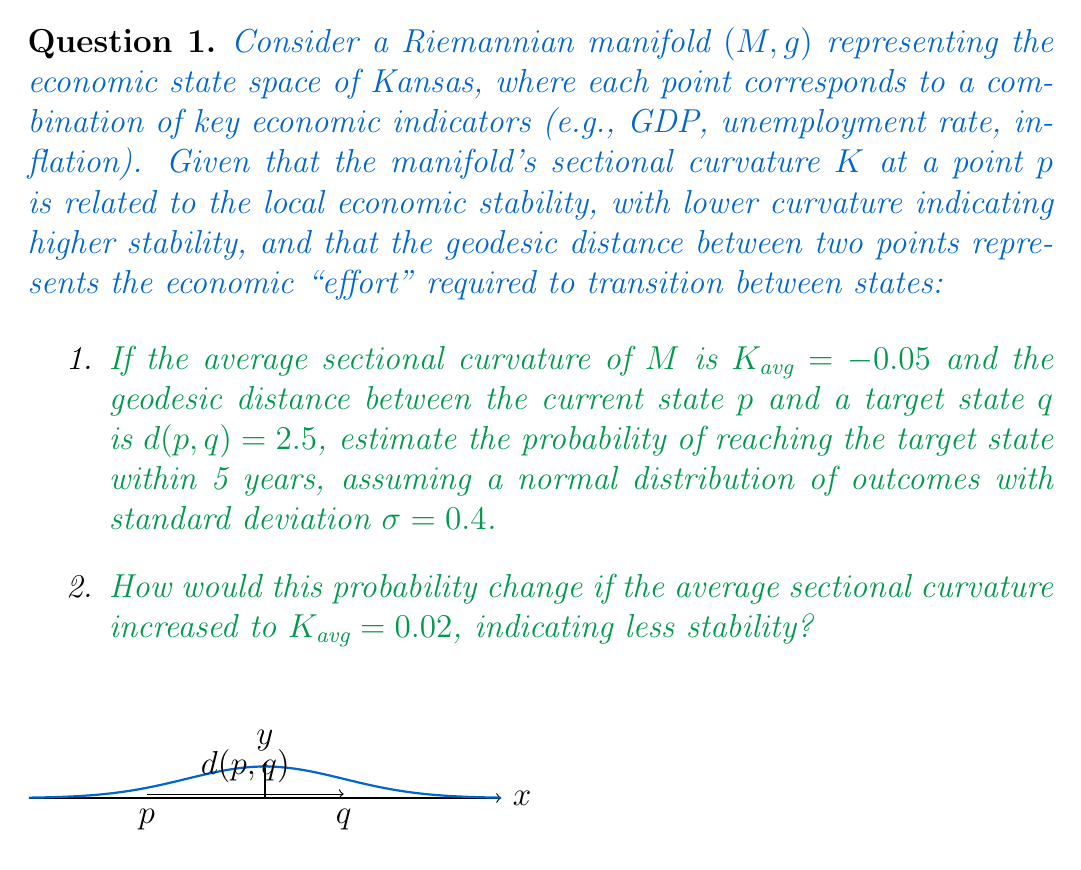Teach me how to tackle this problem. Let's approach this problem step-by-step:

1. First, we need to understand the relationship between sectional curvature and economic stability. Lower curvature (negative values) indicates higher stability, which suggests a higher probability of reaching the target state.

2. The geodesic distance $d(p,q) = 2.5$ represents the economic "effort" required to transition from the current state to the target state.

3. We're assuming a normal distribution of outcomes, which means we can use the standard normal distribution (z-score) to calculate probabilities.

4. To estimate the probability of reaching the target state, we need to calculate the z-score:

   $$z = \frac{x - \mu}{\sigma}$$

   where $x$ is our target distance, $\mu$ is the expected distance traveled in 5 years, and $\sigma$ is the given standard deviation.

5. We can estimate $\mu$ based on the average sectional curvature. A negative curvature suggests faster progress along geodesics. Let's assume:

   $$\mu = \frac{2.5}{1 - K_{avg}} = \frac{2.5}{1 - (-0.05)} = 2.38$$

6. Now we can calculate the z-score:

   $$z = \frac{2.5 - 2.38}{0.4} = 0.3$$

7. Using a standard normal distribution table or calculator, we find that the probability of a z-score less than or equal to 0.3 is approximately 0.6179 or 61.79%.

8. For the second part, with $K_{avg} = 0.02$, we recalculate $\mu$:

   $$\mu = \frac{2.5}{1 - 0.02} = 2.55$$

9. The new z-score is:

   $$z = \frac{2.5 - 2.55}{0.4} = -0.125$$

10. The probability for this z-score is approximately 0.4503 or 45.03%.

The increase in average sectional curvature, indicating less stability, has reduced the probability of reaching the target state within 5 years.
Answer: 1. 61.79%
2. 45.03% 